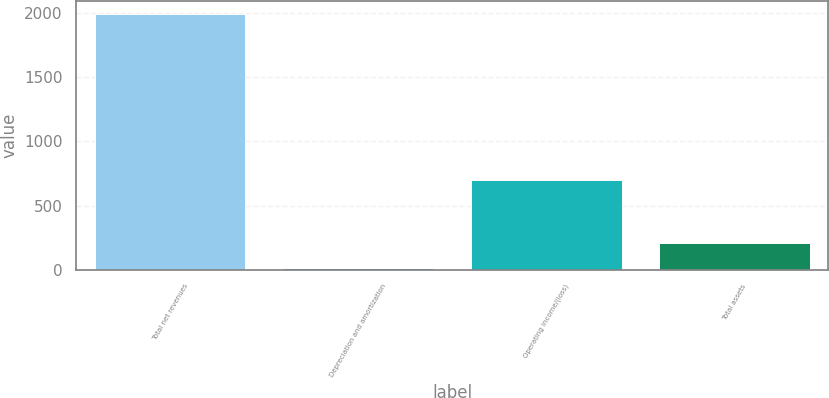<chart> <loc_0><loc_0><loc_500><loc_500><bar_chart><fcel>Total net revenues<fcel>Depreciation and amortization<fcel>Operating income/(loss)<fcel>Total assets<nl><fcel>1992.6<fcel>13<fcel>697.5<fcel>210.96<nl></chart> 